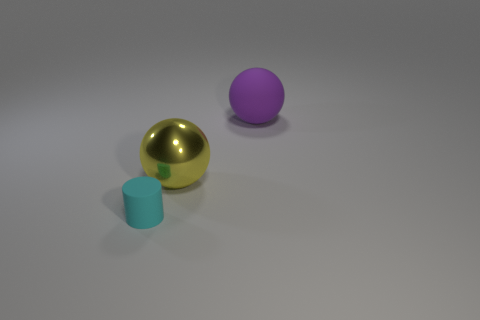What textures are present on the objects? The objects in the image display a variety of textures. The golden sphere has a polished, reflective surface, likely simulating metal. The cyan cylinder has a matte, slightly textured surface resembling plastic or painted wood. Lastly, the large purple ball has a uniform, diffuse surface, which does not strongly reflect light, akin to a matte plastic or rubber ball.  Could you comment on the realism of the objects? Do they look lifelike? The objects exhibit a level of realism consistent with computer-generated imagery. Their perfect geometrical shapes and the way they interact with the light are indicative of 3D rendering, rather than real-world objects. The materials are depicted with enough detail to suggest their possible real-world counterparts, but they retain an idealized, clean appearance that slightly detaches them from reality. 